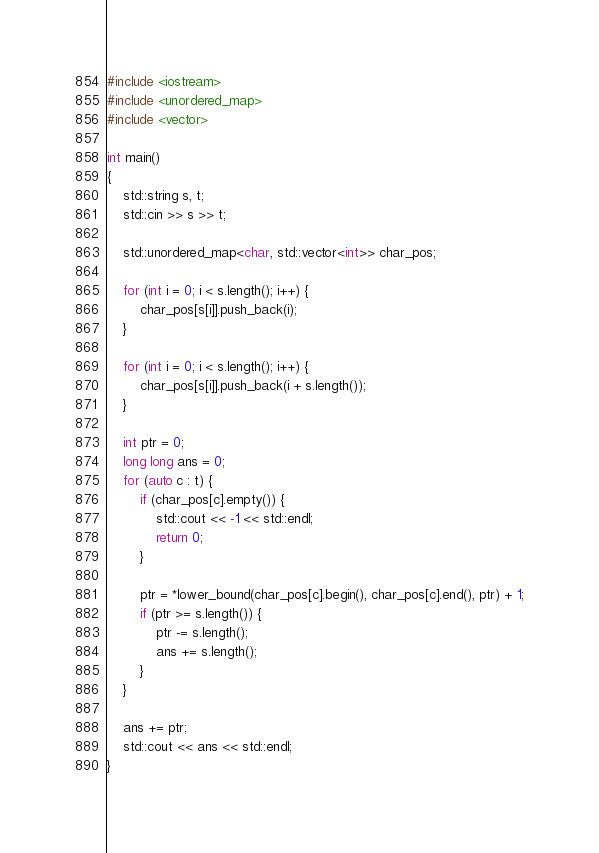Convert code to text. <code><loc_0><loc_0><loc_500><loc_500><_C++_>#include <iostream>
#include <unordered_map>
#include <vector>

int main()
{
    std::string s, t;
    std::cin >> s >> t;

    std::unordered_map<char, std::vector<int>> char_pos;

    for (int i = 0; i < s.length(); i++) {
        char_pos[s[i]].push_back(i);
    }

    for (int i = 0; i < s.length(); i++) {
        char_pos[s[i]].push_back(i + s.length());
    }

    int ptr = 0;
    long long ans = 0;
    for (auto c : t) {
        if (char_pos[c].empty()) {
            std::cout << -1 << std::endl;
            return 0;
        }

        ptr = *lower_bound(char_pos[c].begin(), char_pos[c].end(), ptr) + 1;
        if (ptr >= s.length()) {
            ptr -= s.length();
            ans += s.length();
        }
    }

    ans += ptr;
    std::cout << ans << std::endl;
}
</code> 